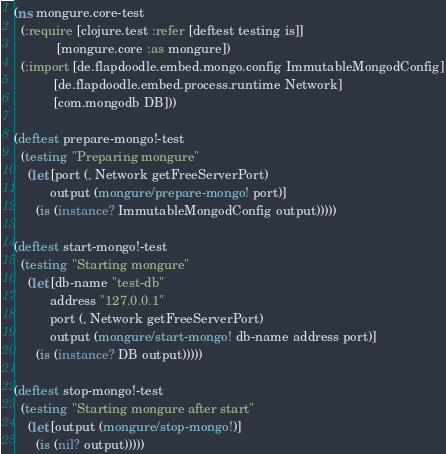Convert code to text. <code><loc_0><loc_0><loc_500><loc_500><_Clojure_>(ns mongure.core-test
  (:require [clojure.test :refer [deftest testing is]]
            [mongure.core :as mongure])
  (:import [de.flapdoodle.embed.mongo.config ImmutableMongodConfig]
           [de.flapdoodle.embed.process.runtime Network]
           [com.mongodb DB]))

(deftest prepare-mongo!-test
  (testing "Preparing mongure"
    (let [port (. Network getFreeServerPort)
          output (mongure/prepare-mongo! port)]
      (is (instance? ImmutableMongodConfig output)))))

(deftest start-mongo!-test
  (testing "Starting mongure"
    (let [db-name "test-db"
          address "127.0.0.1"
          port (. Network getFreeServerPort)
          output (mongure/start-mongo! db-name address port)]
      (is (instance? DB output)))))

(deftest stop-mongo!-test
  (testing "Starting mongure after start"
    (let [output (mongure/stop-mongo!)]
      (is (nil? output)))))
</code> 